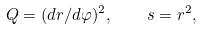Convert formula to latex. <formula><loc_0><loc_0><loc_500><loc_500>Q = ( d r / d \varphi ) ^ { 2 } , \quad s = r ^ { 2 } ,</formula> 